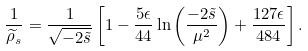<formula> <loc_0><loc_0><loc_500><loc_500>\frac { 1 } { \widetilde { \rho } _ { s } } = \frac { 1 } { \sqrt { - 2 \tilde { s } } } \left [ 1 - \frac { 5 \epsilon } { 4 4 } \ln \left ( \frac { - 2 \tilde { s } } { \mu ^ { 2 } } \right ) + \frac { 1 2 7 \epsilon } { 4 8 4 } \right ] .</formula> 